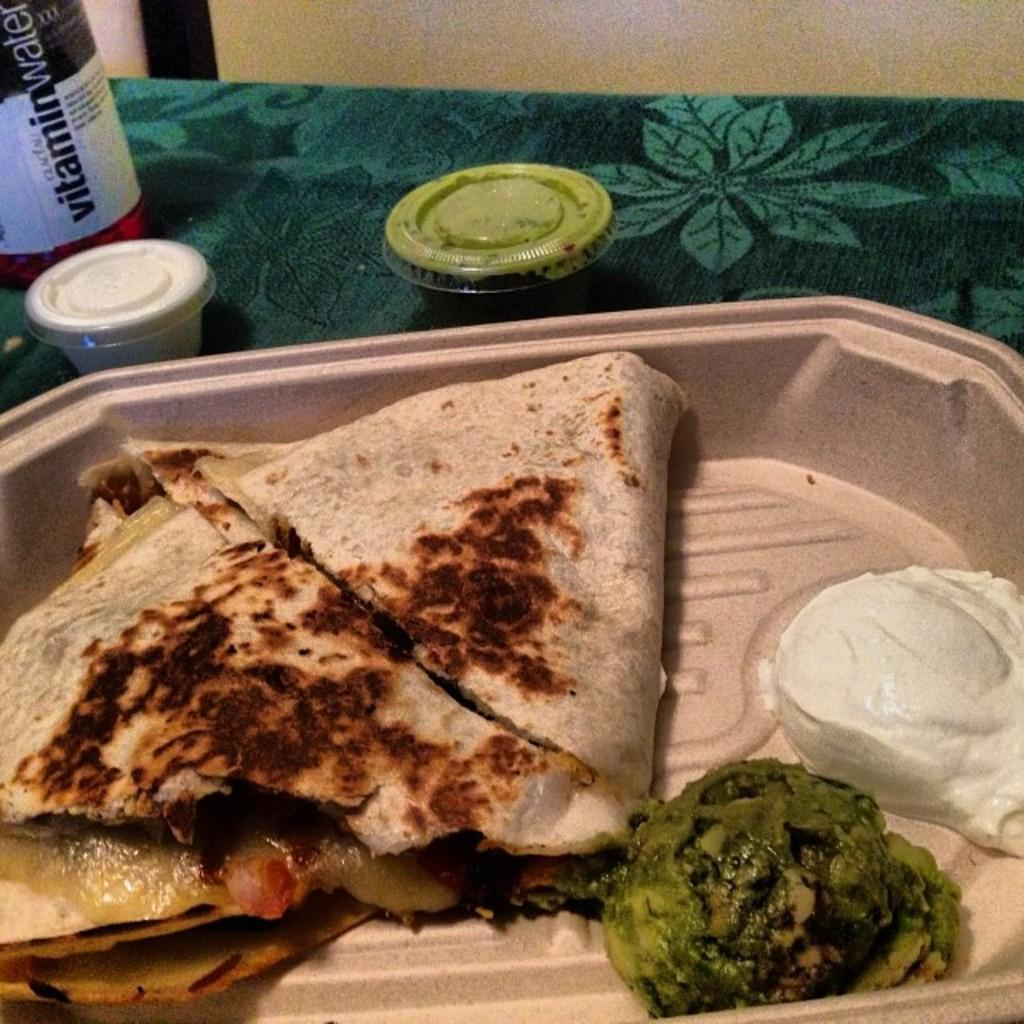What type of objects can be seen in the image? There are food items in the image. How are the food items arranged in the image? The food items are in a plate. Where is the plate with food items located? The plate is placed on a table. What type of view can be seen from the heart in the image? There is no heart or view present in the image; it only features food items in a plate on a table. 